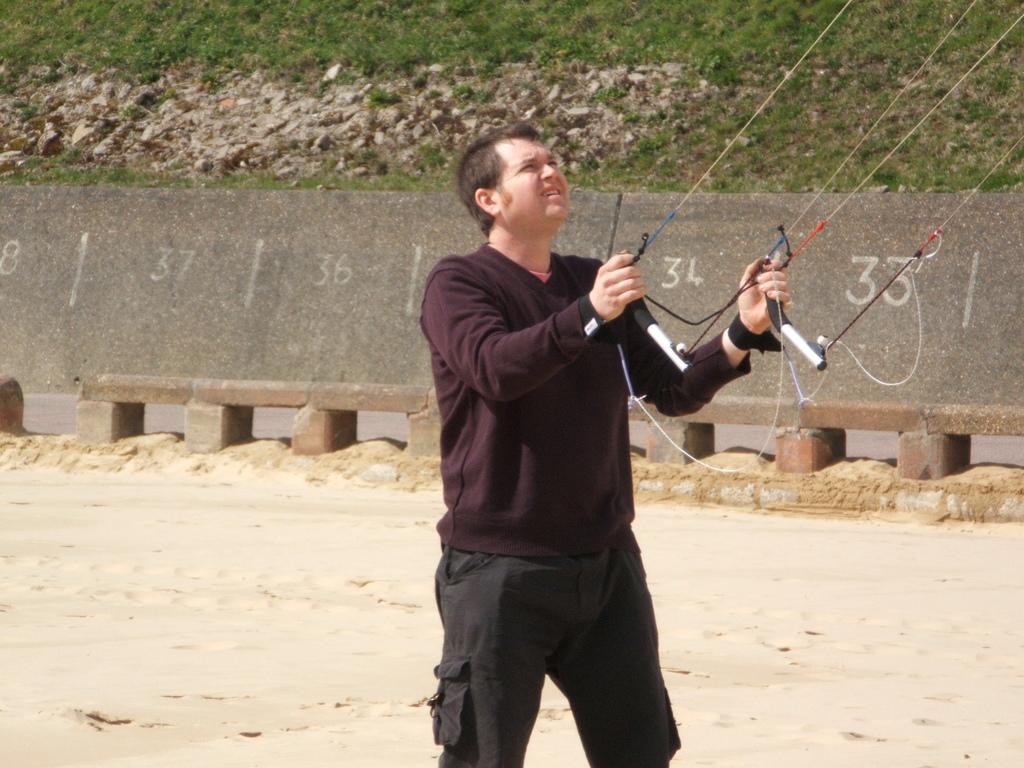What is the main subject of the image? There is a man standing in the image. What is the man holding in the image? The man is holding rods tied with ropes. What can be seen on the wall in the background? There is a wall with numbers on it in the background. What type of natural elements are visible in the background? There are stones and grass visible in the background. What type of plants can be seen growing on the man's self in the image? There are no plants visible on the man's self in the image. Can you tell me how many rats are sitting on the man's shoulder in the image? There are no rats present in the image. 